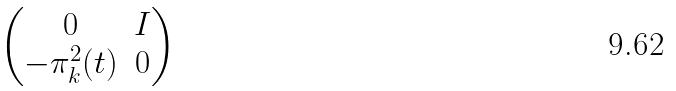Convert formula to latex. <formula><loc_0><loc_0><loc_500><loc_500>\begin{pmatrix} 0 & I \\ - \pi _ { k } ^ { 2 } ( t ) & 0 \end{pmatrix}</formula> 